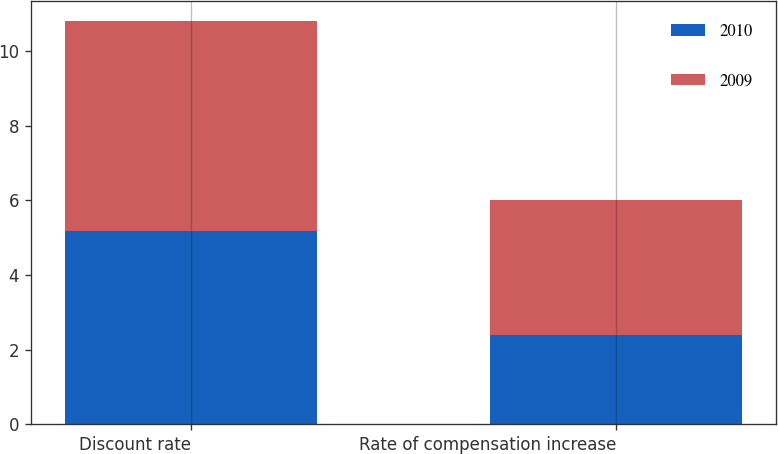<chart> <loc_0><loc_0><loc_500><loc_500><stacked_bar_chart><ecel><fcel>Discount rate<fcel>Rate of compensation increase<nl><fcel>2010<fcel>5.19<fcel>2.39<nl><fcel>2009<fcel>5.62<fcel>3.61<nl></chart> 